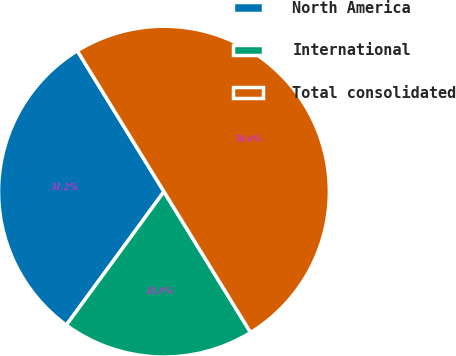Convert chart to OTSL. <chart><loc_0><loc_0><loc_500><loc_500><pie_chart><fcel>North America<fcel>International<fcel>Total consolidated<nl><fcel>31.17%<fcel>18.83%<fcel>50.0%<nl></chart> 